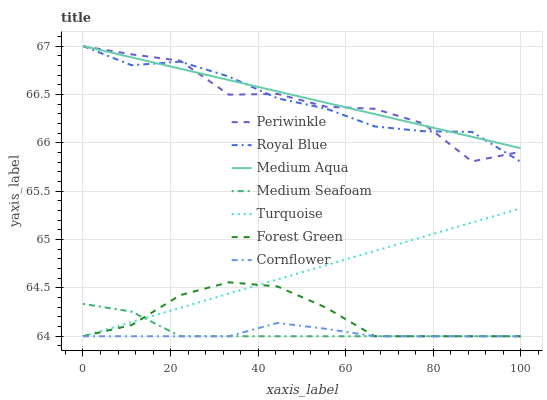Does Cornflower have the minimum area under the curve?
Answer yes or no. Yes. Does Medium Aqua have the maximum area under the curve?
Answer yes or no. Yes. Does Turquoise have the minimum area under the curve?
Answer yes or no. No. Does Turquoise have the maximum area under the curve?
Answer yes or no. No. Is Medium Aqua the smoothest?
Answer yes or no. Yes. Is Periwinkle the roughest?
Answer yes or no. Yes. Is Turquoise the smoothest?
Answer yes or no. No. Is Turquoise the roughest?
Answer yes or no. No. Does Royal Blue have the lowest value?
Answer yes or no. No. Does Turquoise have the highest value?
Answer yes or no. No. Is Medium Seafoam less than Royal Blue?
Answer yes or no. Yes. Is Medium Aqua greater than Forest Green?
Answer yes or no. Yes. Does Medium Seafoam intersect Royal Blue?
Answer yes or no. No. 